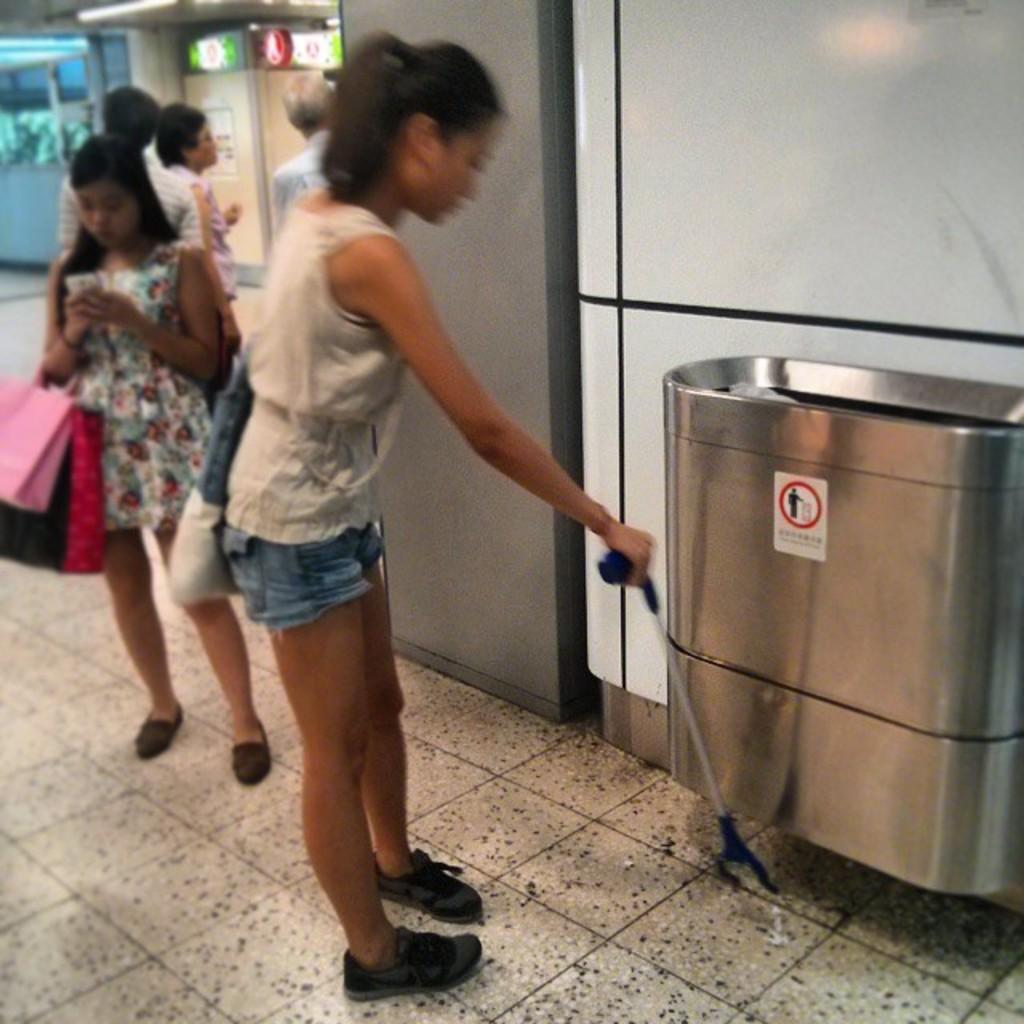In one or two sentences, can you explain what this image depicts? In this image I can see a woman holding a stock wearing a back back another woman standing behind and I can see three more people facing towards the back and I can see a trash can towards the right hand side of the image. 